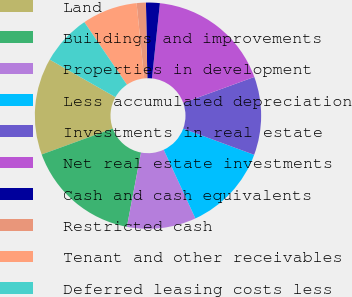Convert chart. <chart><loc_0><loc_0><loc_500><loc_500><pie_chart><fcel>Land<fcel>Buildings and improvements<fcel>Properties in development<fcel>Less accumulated depreciation<fcel>Investments in real estate<fcel>Net real estate investments<fcel>Cash and cash equivalents<fcel>Restricted cash<fcel>Tenant and other receivables<fcel>Deferred leasing costs less<nl><fcel>13.82%<fcel>16.45%<fcel>9.87%<fcel>12.5%<fcel>11.18%<fcel>17.76%<fcel>1.97%<fcel>1.32%<fcel>7.9%<fcel>7.24%<nl></chart> 